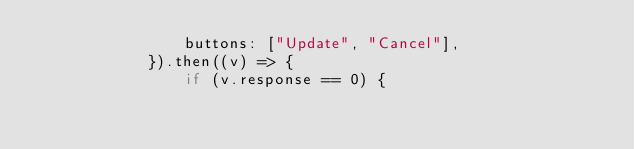<code> <loc_0><loc_0><loc_500><loc_500><_JavaScript_>                buttons: ["Update", "Cancel"],
            }).then((v) => {
                if (v.response == 0) {</code> 